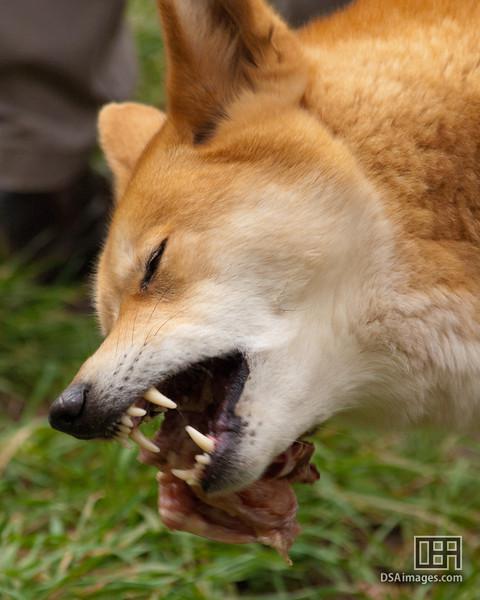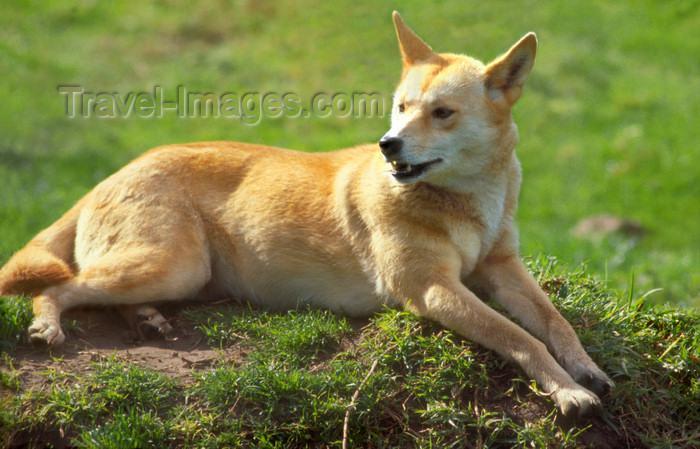The first image is the image on the left, the second image is the image on the right. For the images displayed, is the sentence "The dog in the image on the left has its eyes closed." factually correct? Answer yes or no. Yes. The first image is the image on the left, the second image is the image on the right. For the images shown, is this caption "The dog on the left is sleepy-looking." true? Answer yes or no. No. 